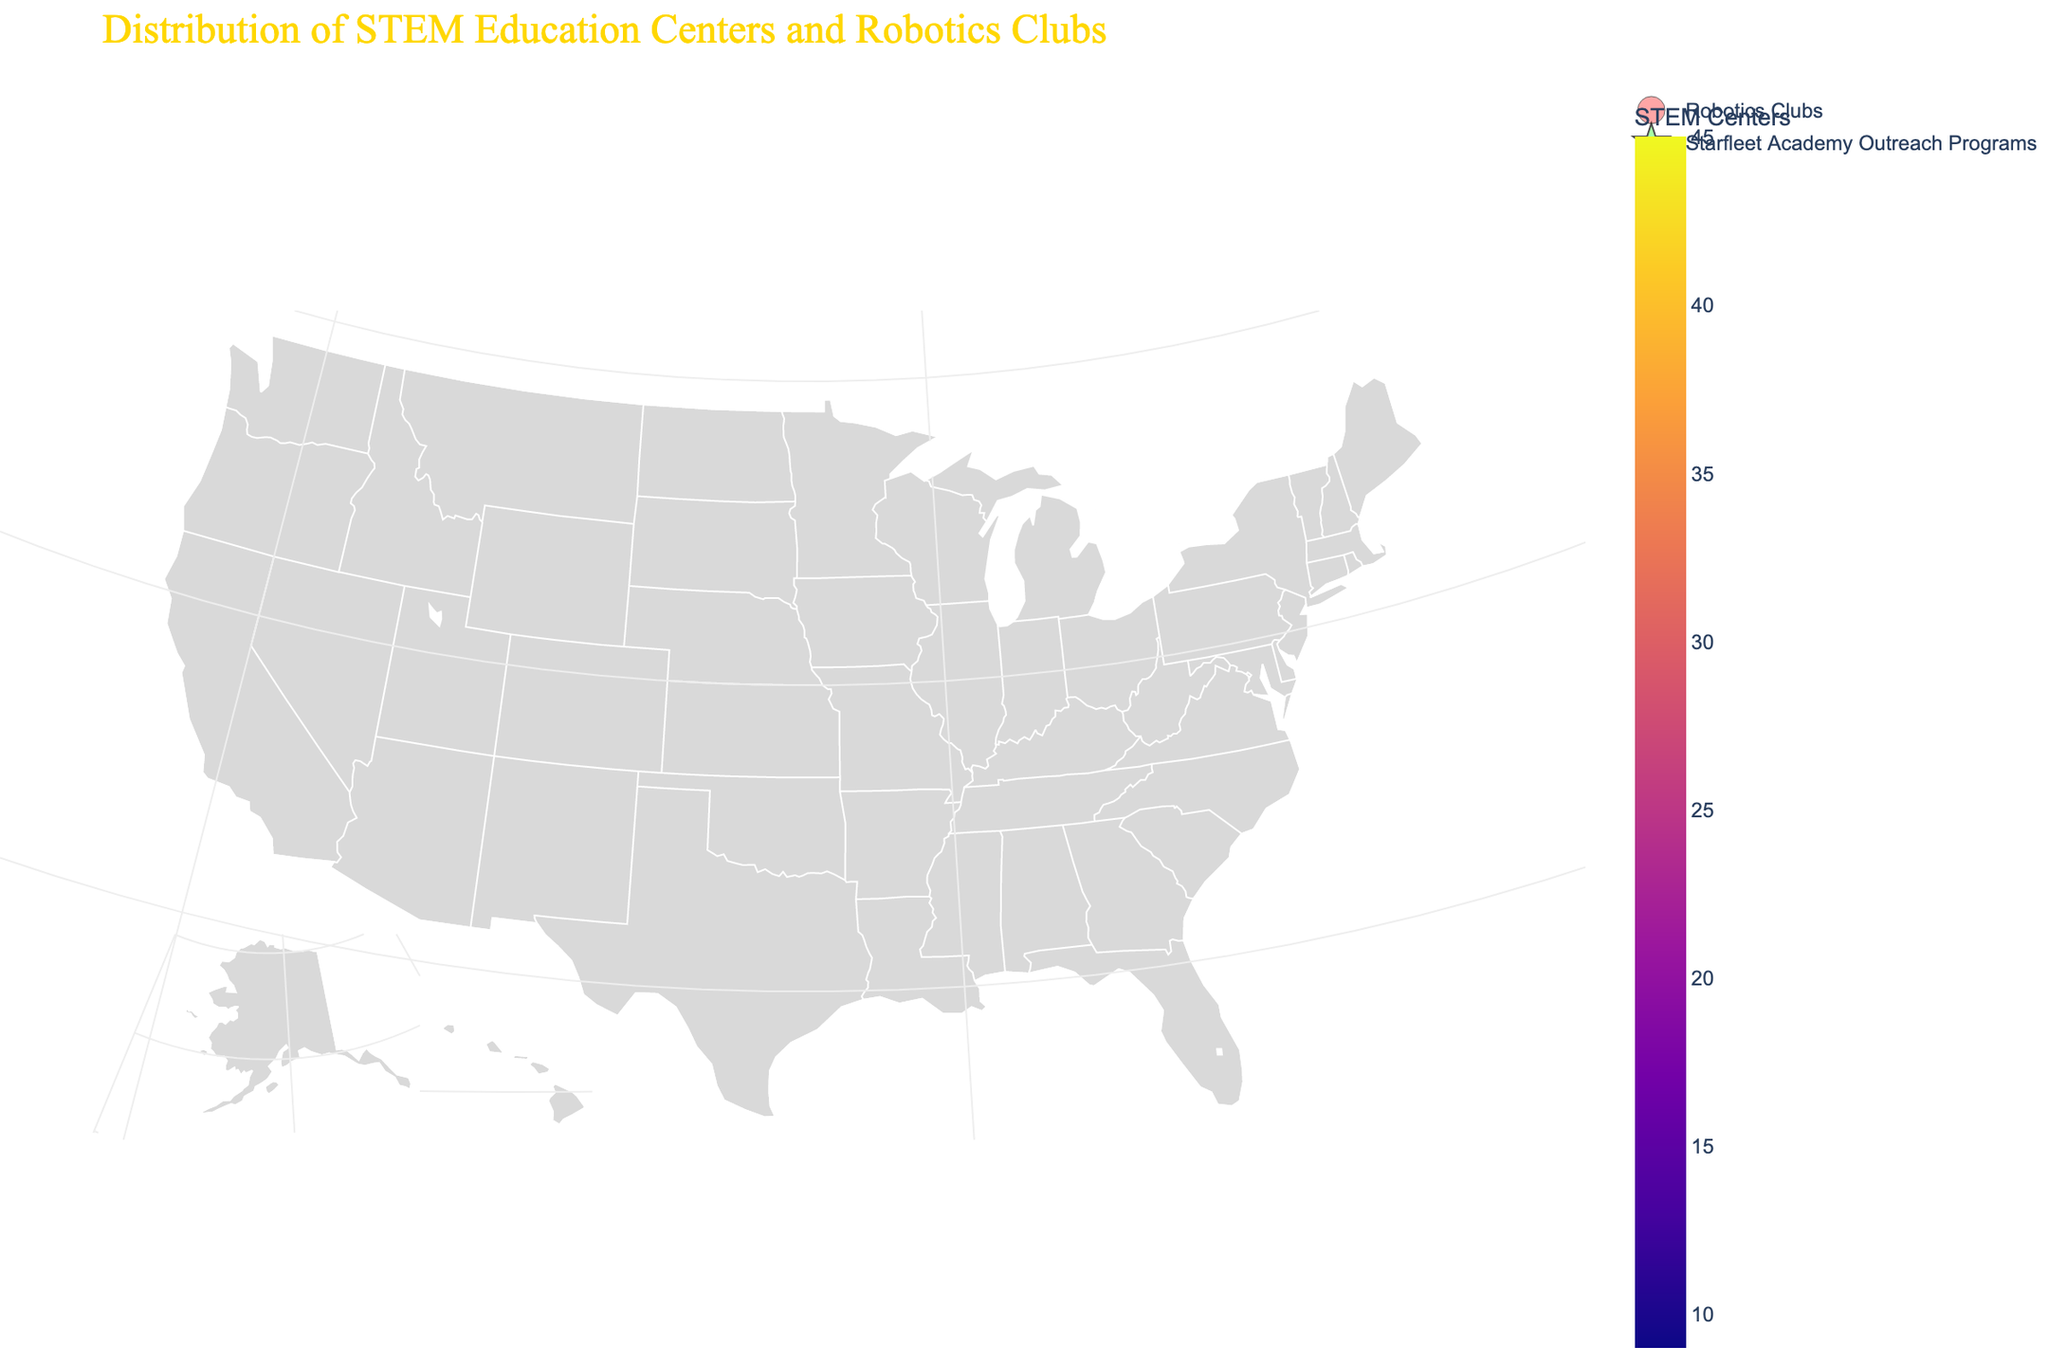What's the title of the plotted figure? The title is usually displayed at the top of the plot. It describes the purpose or contents of the figure.
Answer: Distribution of STEM Education Centers and Robotics Clubs Which region has the highest number of STEM Centers? The color scale on the choropleth map indicates the number of STEM Centers, with darker colors representing higher counts. Look for the region with the darkest color.
Answer: California How many Robotics Clubs are in Texas? The scatter plot superimposed on the choropleth map uses red markers to represent the count of Robotics Clubs, with the size of the markers indicating their number. Locate Texas and hover over or check its red marker.
Answer: 25 What color represents the Starfleet Academy Outreach Programs on the figure? The scatter plot includes different markers for different types of programs. Starfleet Academy Outreach Programs are represented by green star-shaped symbols.
Answer: Green How does the number of Robotics Clubs compare between California and New York? Locate both California and New York and compare the size of the red markers or hover over the regions to see the exact numbers.
Answer: California has more Robotics Clubs than New York (38 vs. 29) What is the sum of STEM Centers in Massachusetts and Florida? Add the number of STEM Centers from Massachusetts (20) and Florida (22).
Answer: 42 Which region has the least number of Starfleet Academy Outreach Programs and how many does it have? The green star shapes represent Starfleet Academy Outreach Programs. Look for the smallest markers and check their count.
Answer: Illinois, Colorado, Georgia, Ohio, North Carolina, Michigan, and Virginia each have 1 What visual element is used to denote the location of Robotics Clubs? The scatter plot uses red circular markers to indicate Robotics Clubs on the choropleth map.
Answer: Red circular markers Are there any regions with an equal number of STEM Centers and Robotics Clubs? Check for regions where the counts of both STEM Centers and Robotics Clubs are the same.
Answer: No Which region has the second highest number of STEM Centers, and how many does it have? After California, identify the region with the next darkest color indicating a high number of STEM Centers.
Answer: New York, with 32 STEM Centers 